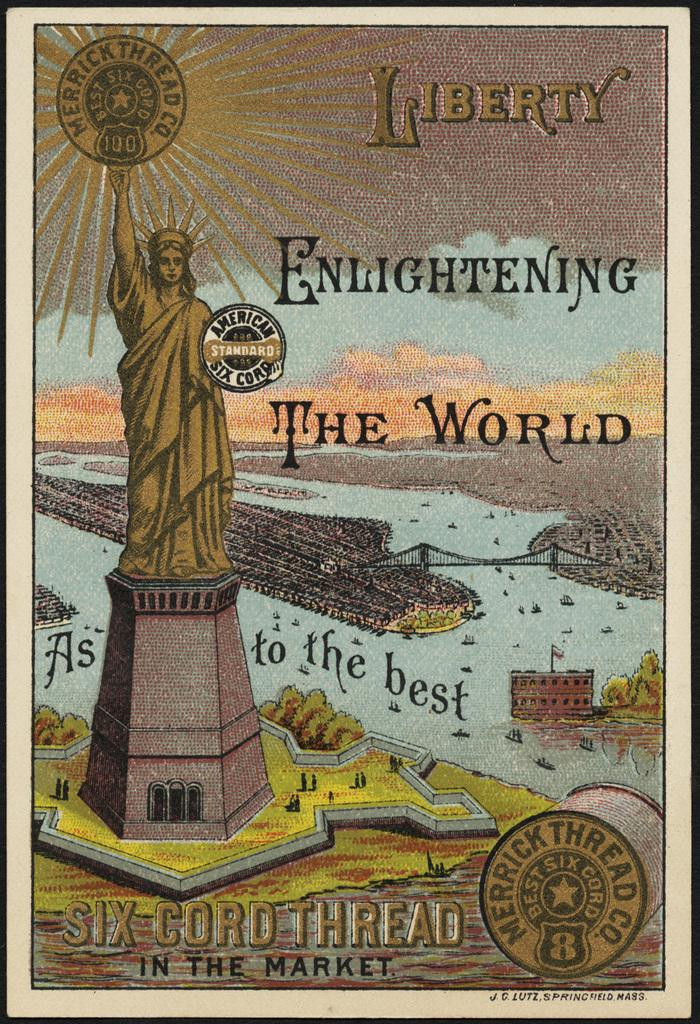<image>
Offer a succinct explanation of the picture presented. A poster featuring the Statue of Liberty says "Six Cord Thread in the Market" at the bottom. 